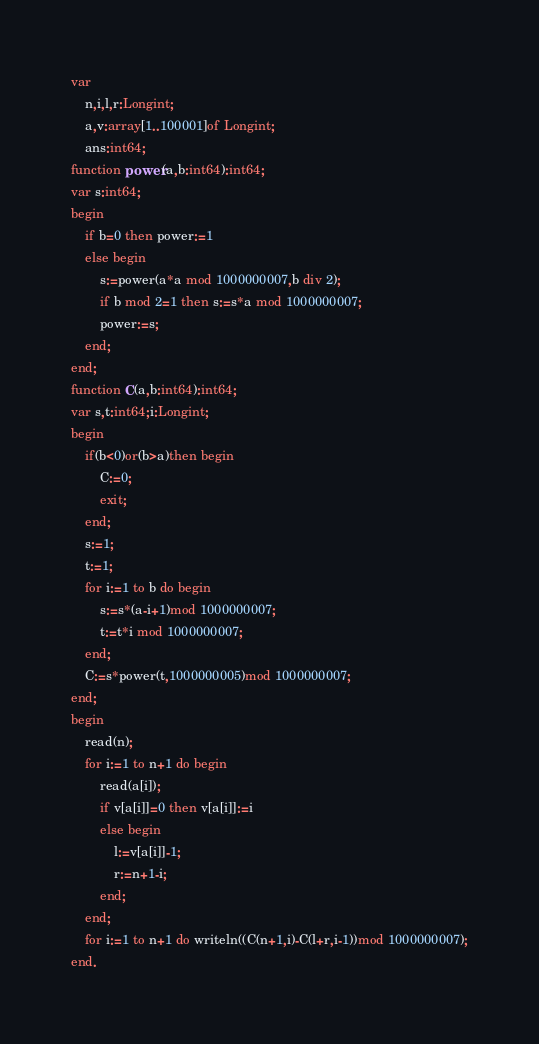<code> <loc_0><loc_0><loc_500><loc_500><_Pascal_>var
	n,i,l,r:Longint;
	a,v:array[1..100001]of Longint;
	ans:int64;
function power(a,b:int64):int64;
var s:int64;
begin
	if b=0 then power:=1
	else begin
		s:=power(a*a mod 1000000007,b div 2);
		if b mod 2=1 then s:=s*a mod 1000000007;
		power:=s;
	end;
end;
function C(a,b:int64):int64;
var s,t:int64;i:Longint;
begin
	if(b<0)or(b>a)then begin
		C:=0;
		exit;
	end;
	s:=1;
	t:=1;
	for i:=1 to b do begin
		s:=s*(a-i+1)mod 1000000007;
		t:=t*i mod 1000000007;
	end;
	C:=s*power(t,1000000005)mod 1000000007;
end;
begin
	read(n);
	for i:=1 to n+1 do begin
		read(a[i]);
		if v[a[i]]=0 then v[a[i]]:=i
		else begin
			l:=v[a[i]]-1;
			r:=n+1-i;
		end;
	end;
	for i:=1 to n+1 do writeln((C(n+1,i)-C(l+r,i-1))mod 1000000007);
end.
</code> 